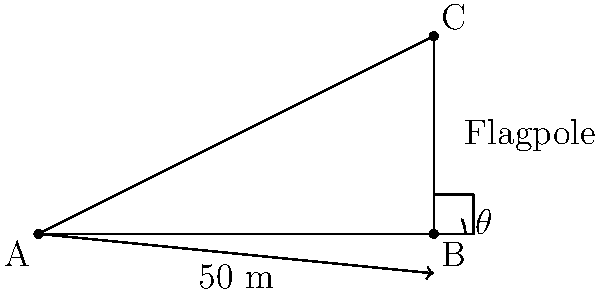A town hall wants to raise a new flagpole, but they need to determine its height first. From a point on the ground 50 meters away from the base of the flagpole, the angle of elevation to the top of the flagpole is measured to be 26.57°. Using this information, calculate the height of the flagpole to the nearest meter. How might this calculation be useful in civic planning and community engagement? Let's approach this step-by-step using trigonometry:

1) We can model this scenario as a right triangle, where:
   - The base of the triangle is the distance from the observation point to the flagpole (50 m)
   - The height of the triangle is the height of the flagpole (what we're solving for)
   - The angle of elevation is the angle between the base and the line of sight (26.57°)

2) In this right triangle, we know:
   - The adjacent side (base) = 50 m
   - The angle = 26.57°
   - We need to find the opposite side (height)

3) This scenario calls for the tangent function, as it relates the opposite and adjacent sides:

   $\tan(\theta) = \frac{\text{opposite}}{\text{adjacent}}$

4) Plugging in our known values:

   $\tan(26.57°) = \frac{\text{height}}{50}$

5) Solving for height:

   $\text{height} = 50 \times \tan(26.57°)$

6) Using a calculator (or trig tables):

   $\text{height} = 50 \times 0.4999 = 24.995$ meters

7) Rounding to the nearest meter:

   $\text{height} \approx 25$ meters

This calculation is crucial for civic planning as it helps determine the visual impact of the flagpole, ensures it meets local zoning regulations, and aids in planning installation logistics. It also provides a tangible connection between mathematics and civic symbols, potentially increasing community engagement in local government affairs.
Answer: 25 meters 